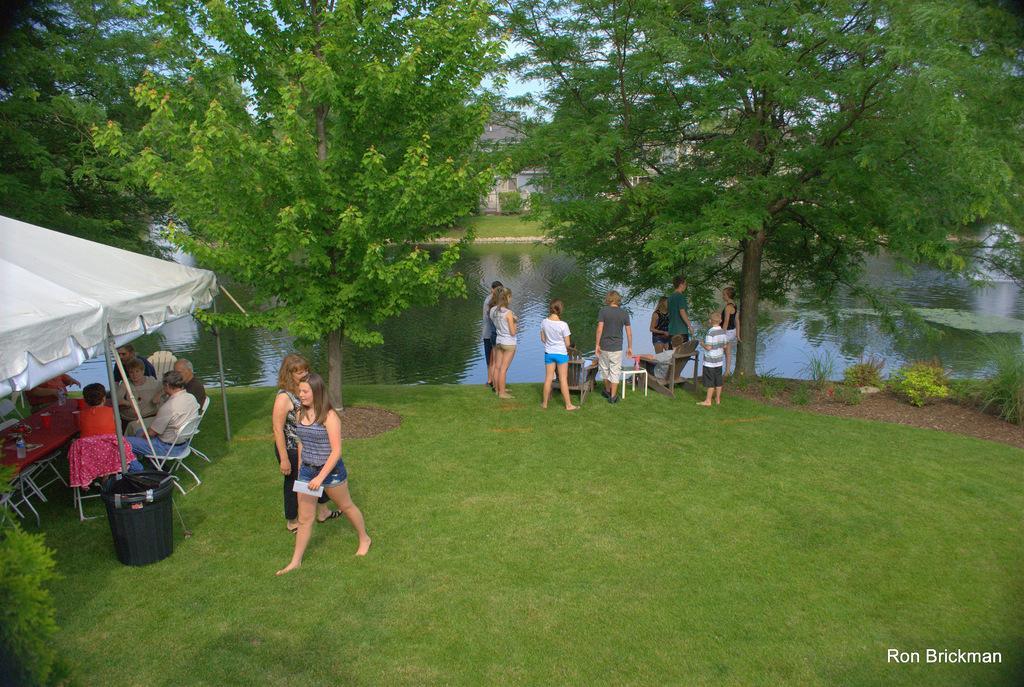In one or two sentences, can you explain what this image depicts? In this picture there is grassland at the bottom side of the image and there are people in the center of the image, there is a tent on the left side of the image, there are trees at the top side of the image, there is water in the center of the image. 